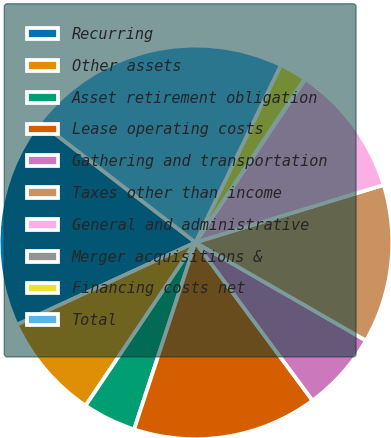Convert chart. <chart><loc_0><loc_0><loc_500><loc_500><pie_chart><fcel>Recurring<fcel>Other assets<fcel>Asset retirement obligation<fcel>Lease operating costs<fcel>Gathering and transportation<fcel>Taxes other than income<fcel>General and administrative<fcel>Merger acquisitions &<fcel>Financing costs net<fcel>Total<nl><fcel>17.35%<fcel>8.7%<fcel>4.38%<fcel>15.19%<fcel>6.54%<fcel>13.03%<fcel>10.86%<fcel>0.06%<fcel>2.22%<fcel>21.67%<nl></chart> 